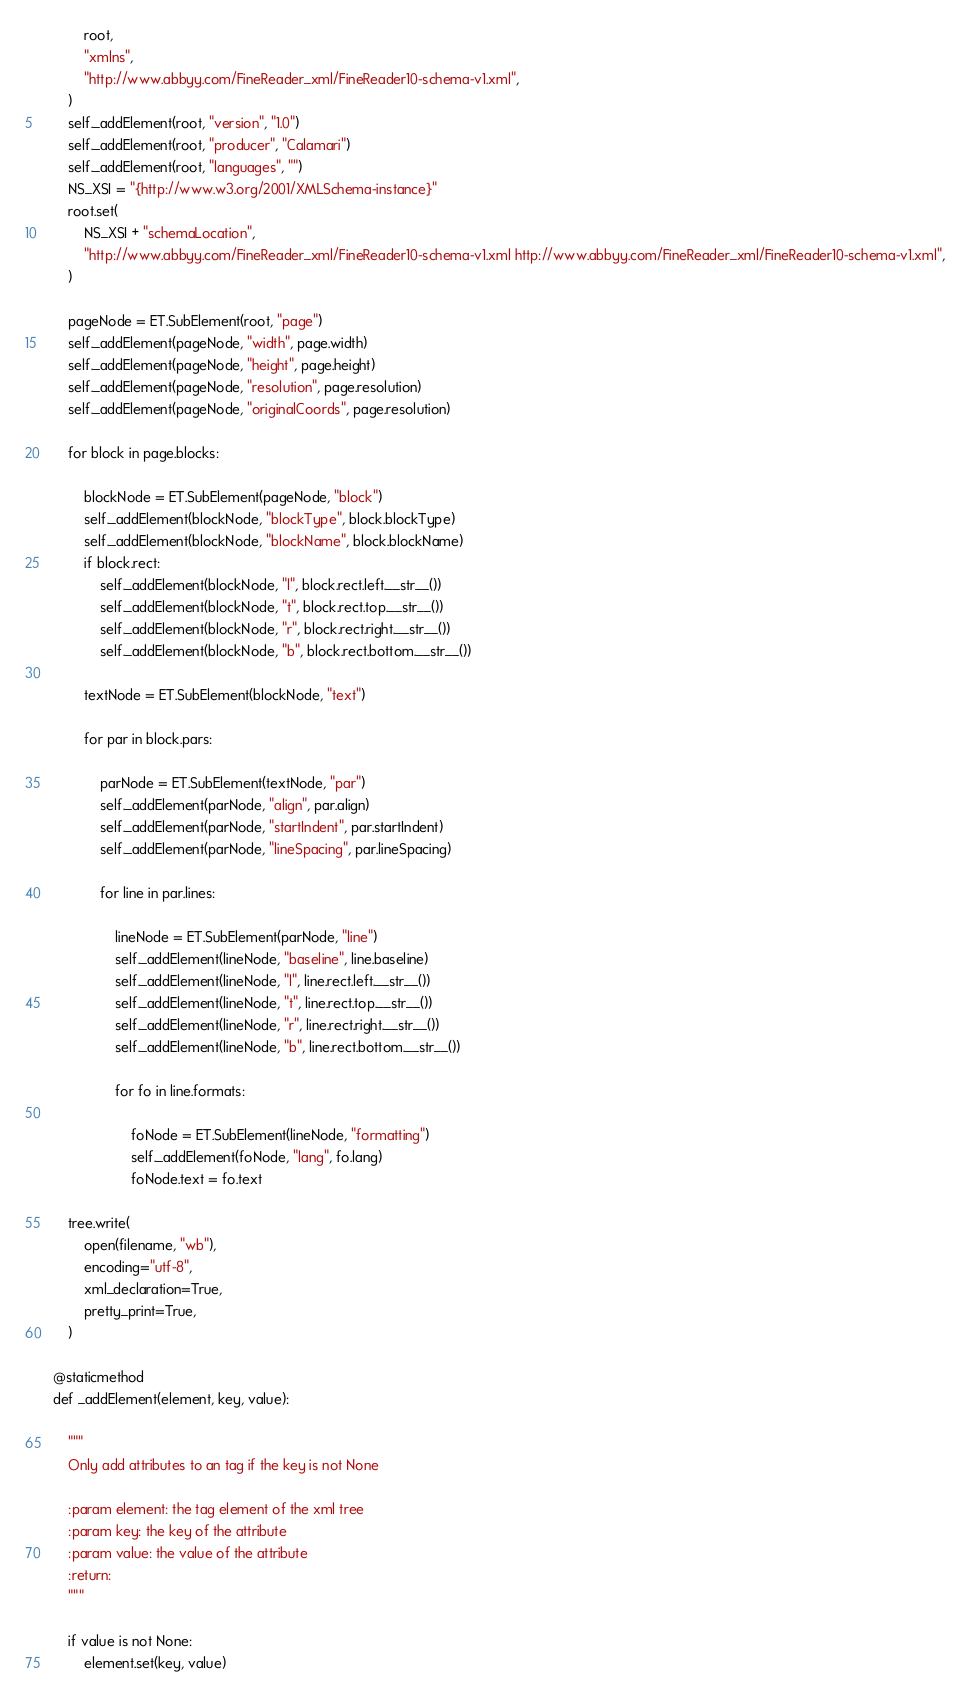Convert code to text. <code><loc_0><loc_0><loc_500><loc_500><_Python_>            root,
            "xmlns",
            "http://www.abbyy.com/FineReader_xml/FineReader10-schema-v1.xml",
        )
        self._addElement(root, "version", "1.0")
        self._addElement(root, "producer", "Calamari")
        self._addElement(root, "languages", "")
        NS_XSI = "{http://www.w3.org/2001/XMLSchema-instance}"
        root.set(
            NS_XSI + "schemaLocation",
            "http://www.abbyy.com/FineReader_xml/FineReader10-schema-v1.xml http://www.abbyy.com/FineReader_xml/FineReader10-schema-v1.xml",
        )

        pageNode = ET.SubElement(root, "page")
        self._addElement(pageNode, "width", page.width)
        self._addElement(pageNode, "height", page.height)
        self._addElement(pageNode, "resolution", page.resolution)
        self._addElement(pageNode, "originalCoords", page.resolution)

        for block in page.blocks:

            blockNode = ET.SubElement(pageNode, "block")
            self._addElement(blockNode, "blockType", block.blockType)
            self._addElement(blockNode, "blockName", block.blockName)
            if block.rect:
                self._addElement(blockNode, "l", block.rect.left.__str__())
                self._addElement(blockNode, "t", block.rect.top.__str__())
                self._addElement(blockNode, "r", block.rect.right.__str__())
                self._addElement(blockNode, "b", block.rect.bottom.__str__())

            textNode = ET.SubElement(blockNode, "text")

            for par in block.pars:

                parNode = ET.SubElement(textNode, "par")
                self._addElement(parNode, "align", par.align)
                self._addElement(parNode, "startIndent", par.startIndent)
                self._addElement(parNode, "lineSpacing", par.lineSpacing)

                for line in par.lines:

                    lineNode = ET.SubElement(parNode, "line")
                    self._addElement(lineNode, "baseline", line.baseline)
                    self._addElement(lineNode, "l", line.rect.left.__str__())
                    self._addElement(lineNode, "t", line.rect.top.__str__())
                    self._addElement(lineNode, "r", line.rect.right.__str__())
                    self._addElement(lineNode, "b", line.rect.bottom.__str__())

                    for fo in line.formats:

                        foNode = ET.SubElement(lineNode, "formatting")
                        self._addElement(foNode, "lang", fo.lang)
                        foNode.text = fo.text

        tree.write(
            open(filename, "wb"),
            encoding="utf-8",
            xml_declaration=True,
            pretty_print=True,
        )

    @staticmethod
    def _addElement(element, key, value):

        """
        Only add attributes to an tag if the key is not None

        :param element: the tag element of the xml tree
        :param key: the key of the attribute
        :param value: the value of the attribute
        :return:
        """

        if value is not None:
            element.set(key, value)
</code> 